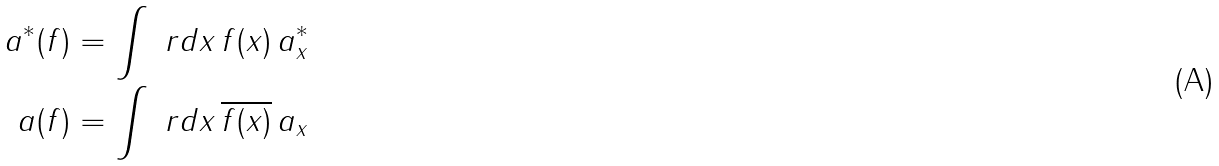Convert formula to latex. <formula><loc_0><loc_0><loc_500><loc_500>a ^ { * } ( f ) & = \int \ r d x \, f ( x ) \, a _ { x } ^ { * } \\ a ( f ) & = \int \ r d x \, \overline { f ( x ) } \, a _ { x }</formula> 